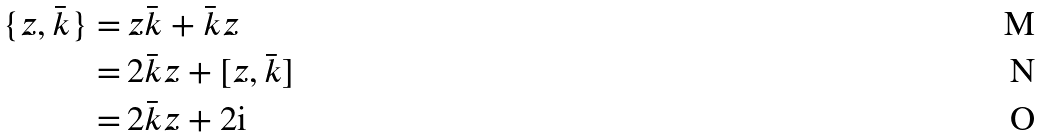<formula> <loc_0><loc_0><loc_500><loc_500>\{ z , \bar { k } \} = & \, z \bar { k } + \bar { k } z \\ = & \, 2 \bar { k } z + [ z , \bar { k } ] \\ = & \, 2 \bar { k } z + 2 \text {i}</formula> 